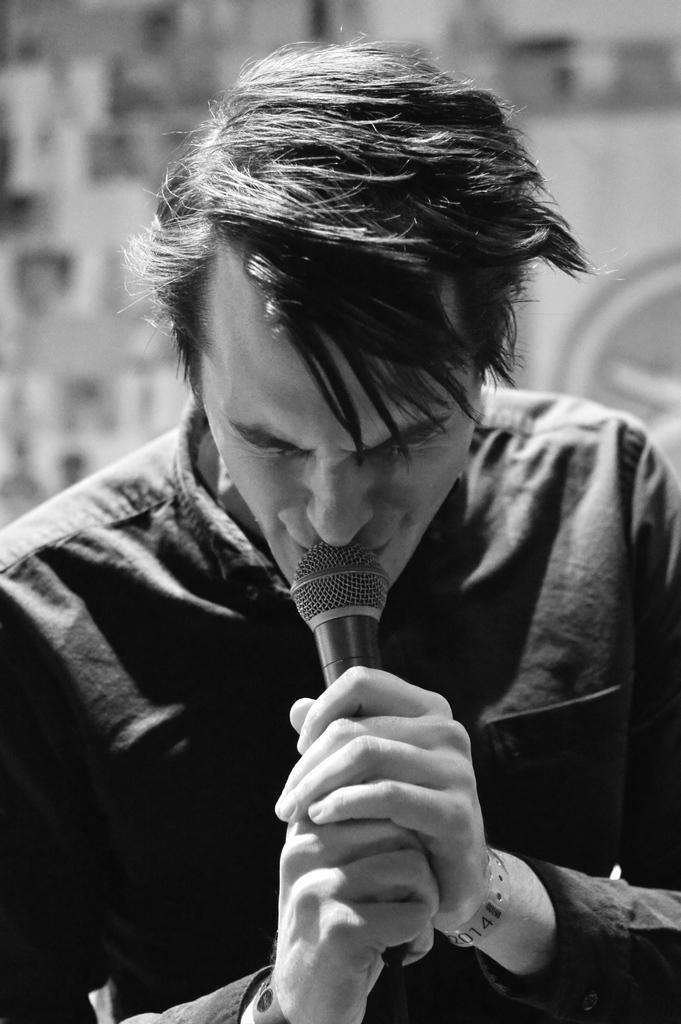How would you summarize this image in a sentence or two? In this picture we can see man holding mic in his hand and singing and the background it is blurry. 